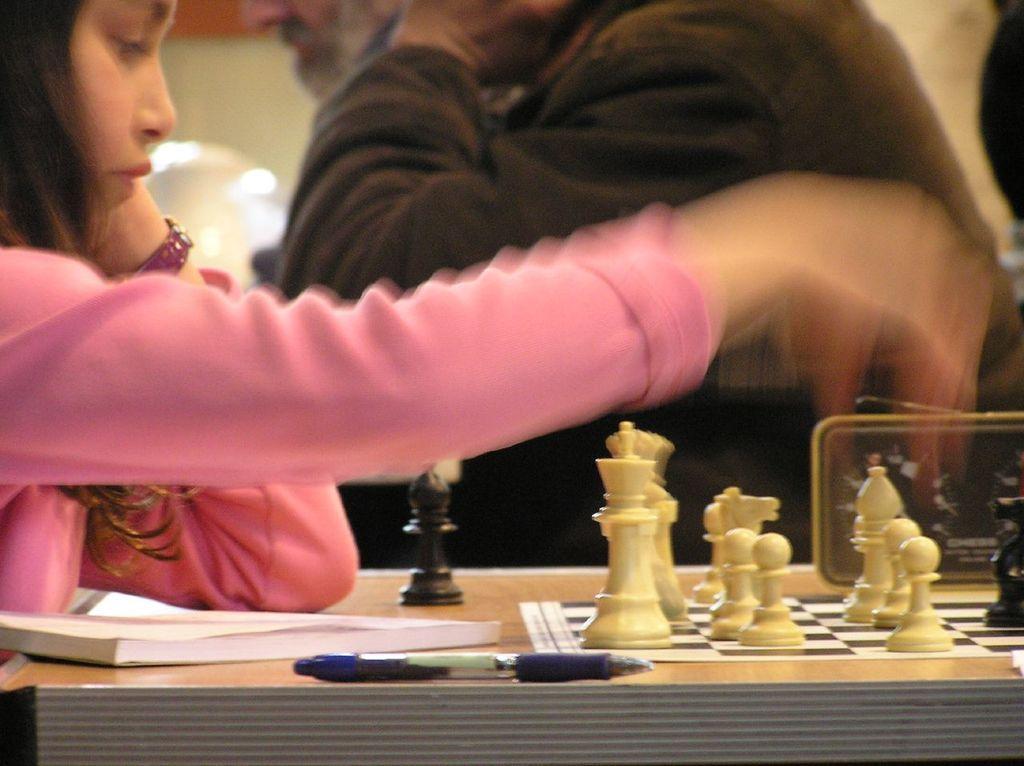Please provide a concise description of this image. In this picture there is a girl playing chess. She wore a pink dress and a watch. There is table in front of her. On the table there is book, pen, chess board and chess coins. In the background there is a man. 